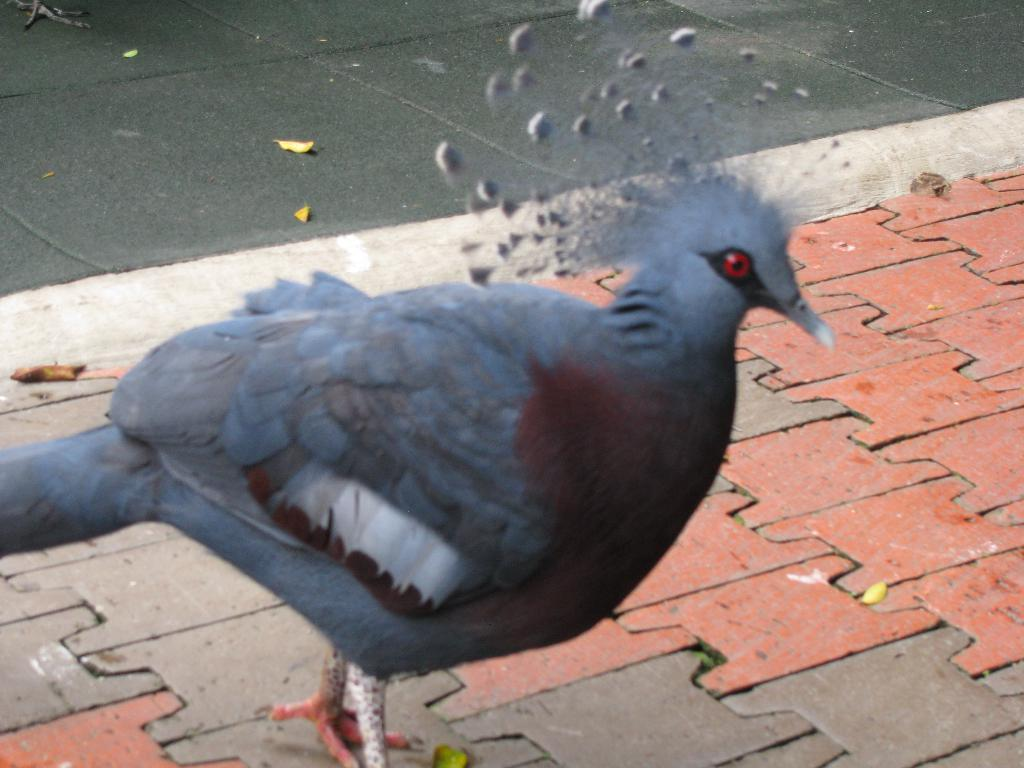What type of animal is in the image? There is a bird in the image. Where is the bird located? The bird is standing on the ground. What can be seen in the background of the image? There are leaves visible in the background of the image. What is the value of the discovery made by the bird in the image? There is no discovery made by the bird in the image, and therefore no value can be assigned to it. 